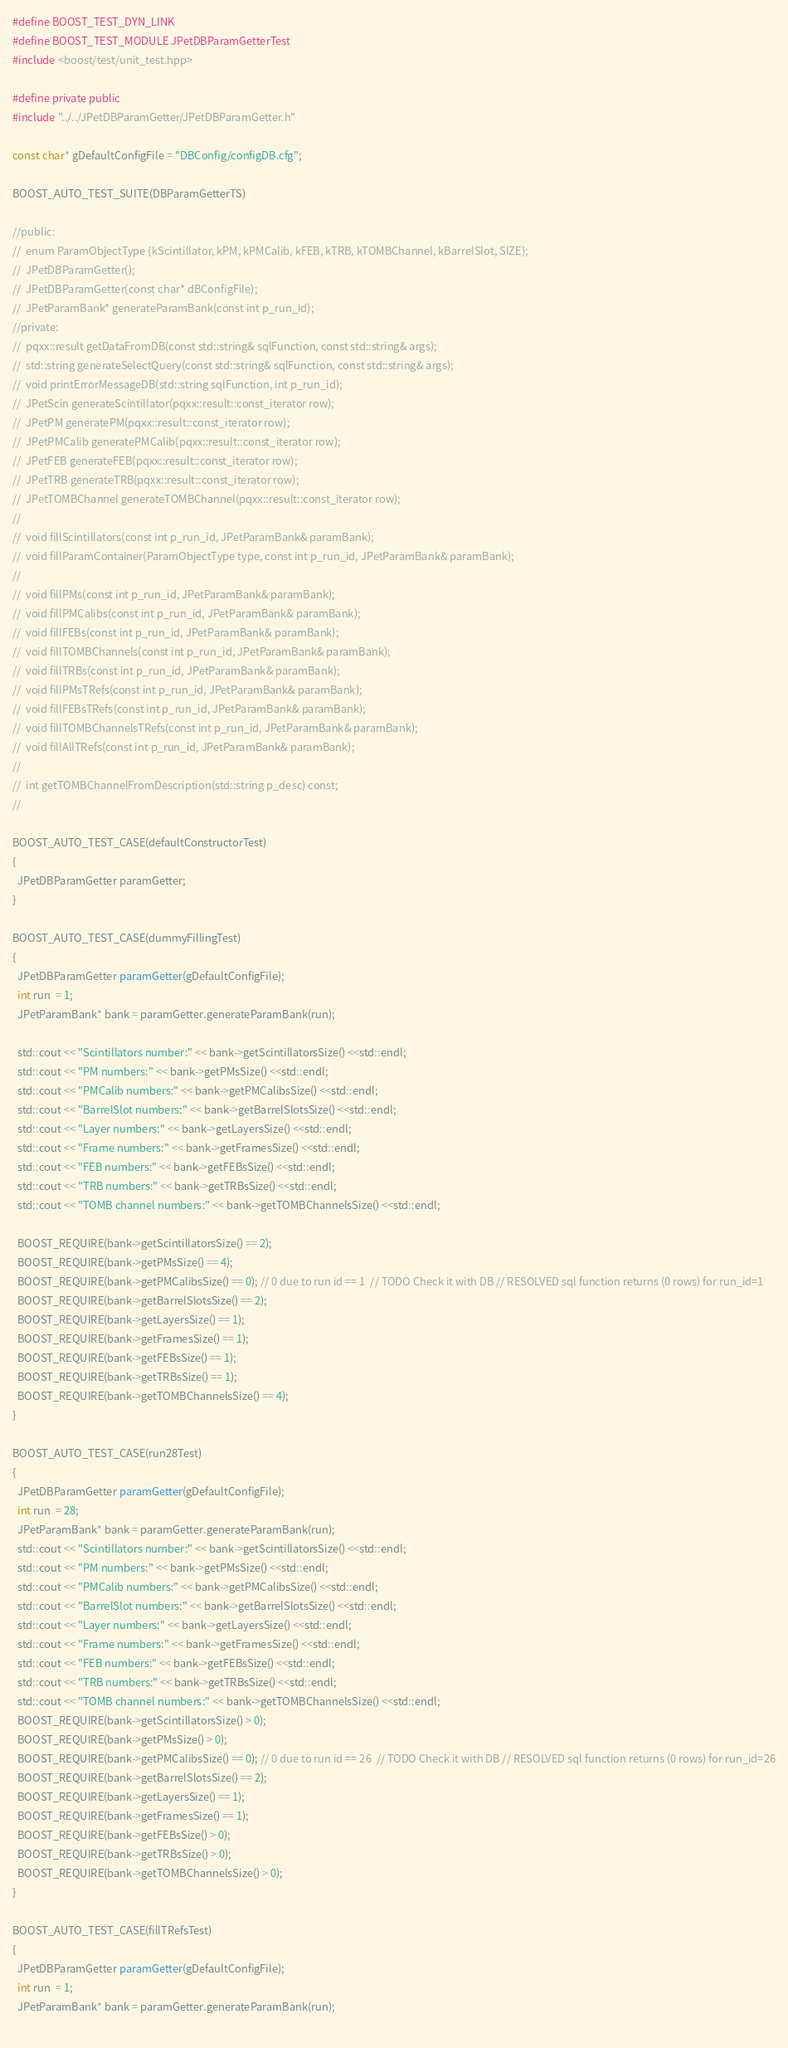Convert code to text. <code><loc_0><loc_0><loc_500><loc_500><_C++_>#define BOOST_TEST_DYN_LINK
#define BOOST_TEST_MODULE JPetDBParamGetterTest
#include <boost/test/unit_test.hpp>

#define private public
#include "../../JPetDBParamGetter/JPetDBParamGetter.h"

const char* gDefaultConfigFile = "DBConfig/configDB.cfg";

BOOST_AUTO_TEST_SUITE(DBParamGetterTS)

//public:
//  enum ParamObjectType {kScintillator, kPM, kPMCalib, kFEB, kTRB, kTOMBChannel, kBarrelSlot, SIZE};
//  JPetDBParamGetter();
//  JPetDBParamGetter(const char* dBConfigFile);
//  JPetParamBank* generateParamBank(const int p_run_id);
//private:
//  pqxx::result getDataFromDB(const std::string& sqlFunction, const std::string& args);
//  std::string generateSelectQuery(const std::string& sqlFunction, const std::string& args);
//  void printErrorMessageDB(std::string sqlFunction, int p_run_id);
//  JPetScin generateScintillator(pqxx::result::const_iterator row);
//  JPetPM generatePM(pqxx::result::const_iterator row);
//  JPetPMCalib generatePMCalib(pqxx::result::const_iterator row);
//  JPetFEB generateFEB(pqxx::result::const_iterator row);
//  JPetTRB generateTRB(pqxx::result::const_iterator row);
//  JPetTOMBChannel generateTOMBChannel(pqxx::result::const_iterator row);
//
//  void fillScintillators(const int p_run_id, JPetParamBank& paramBank);
//  void fillParamContainer(ParamObjectType type, const int p_run_id, JPetParamBank& paramBank);
//
//  void fillPMs(const int p_run_id, JPetParamBank& paramBank);
//  void fillPMCalibs(const int p_run_id, JPetParamBank& paramBank);
//  void fillFEBs(const int p_run_id, JPetParamBank& paramBank);
//  void fillTOMBChannels(const int p_run_id, JPetParamBank& paramBank);
//  void fillTRBs(const int p_run_id, JPetParamBank& paramBank);
//  void fillPMsTRefs(const int p_run_id, JPetParamBank& paramBank);
//  void fillFEBsTRefs(const int p_run_id, JPetParamBank& paramBank);
//  void fillTOMBChannelsTRefs(const int p_run_id, JPetParamBank& paramBank);
//  void fillAllTRefs(const int p_run_id, JPetParamBank& paramBank);
//
//  int getTOMBChannelFromDescription(std::string p_desc) const;
//

BOOST_AUTO_TEST_CASE(defaultConstructorTest)
{
  JPetDBParamGetter paramGetter;
}

BOOST_AUTO_TEST_CASE(dummyFillingTest)
{
  JPetDBParamGetter paramGetter(gDefaultConfigFile);
  int run  = 1;
  JPetParamBank* bank = paramGetter.generateParamBank(run);
  
  std::cout << "Scintillators number:" << bank->getScintillatorsSize() <<std::endl;
  std::cout << "PM numbers:" << bank->getPMsSize() <<std::endl;
  std::cout << "PMCalib numbers:" << bank->getPMCalibsSize() <<std::endl;
  std::cout << "BarrelSlot numbers:" << bank->getBarrelSlotsSize() <<std::endl;
  std::cout << "Layer numbers:" << bank->getLayersSize() <<std::endl;
  std::cout << "Frame numbers:" << bank->getFramesSize() <<std::endl;
  std::cout << "FEB numbers:" << bank->getFEBsSize() <<std::endl;
  std::cout << "TRB numbers:" << bank->getTRBsSize() <<std::endl;
  std::cout << "TOMB channel numbers:" << bank->getTOMBChannelsSize() <<std::endl;

  BOOST_REQUIRE(bank->getScintillatorsSize() == 2);
  BOOST_REQUIRE(bank->getPMsSize() == 4);
  BOOST_REQUIRE(bank->getPMCalibsSize() == 0); // 0 due to run id == 1  // TODO Check it with DB // RESOLVED sql function returns (0 rows) for run_id=1
  BOOST_REQUIRE(bank->getBarrelSlotsSize() == 2);
  BOOST_REQUIRE(bank->getLayersSize() == 1);
  BOOST_REQUIRE(bank->getFramesSize() == 1);
  BOOST_REQUIRE(bank->getFEBsSize() == 1);
  BOOST_REQUIRE(bank->getTRBsSize() == 1);
  BOOST_REQUIRE(bank->getTOMBChannelsSize() == 4);
}

BOOST_AUTO_TEST_CASE(run28Test)
{
  JPetDBParamGetter paramGetter(gDefaultConfigFile);
  int run  = 28;
  JPetParamBank* bank = paramGetter.generateParamBank(run);
  std::cout << "Scintillators number:" << bank->getScintillatorsSize() <<std::endl;
  std::cout << "PM numbers:" << bank->getPMsSize() <<std::endl;
  std::cout << "PMCalib numbers:" << bank->getPMCalibsSize() <<std::endl;
  std::cout << "BarrelSlot numbers:" << bank->getBarrelSlotsSize() <<std::endl;
  std::cout << "Layer numbers:" << bank->getLayersSize() <<std::endl;
  std::cout << "Frame numbers:" << bank->getFramesSize() <<std::endl;
  std::cout << "FEB numbers:" << bank->getFEBsSize() <<std::endl;
  std::cout << "TRB numbers:" << bank->getTRBsSize() <<std::endl;
  std::cout << "TOMB channel numbers:" << bank->getTOMBChannelsSize() <<std::endl;
  BOOST_REQUIRE(bank->getScintillatorsSize() > 0);
  BOOST_REQUIRE(bank->getPMsSize() > 0);
  BOOST_REQUIRE(bank->getPMCalibsSize() == 0); // 0 due to run id == 26  // TODO Check it with DB // RESOLVED sql function returns (0 rows) for run_id=26
  BOOST_REQUIRE(bank->getBarrelSlotsSize() == 2);
  BOOST_REQUIRE(bank->getLayersSize() == 1);
  BOOST_REQUIRE(bank->getFramesSize() == 1);
  BOOST_REQUIRE(bank->getFEBsSize() > 0);
  BOOST_REQUIRE(bank->getTRBsSize() > 0);
  BOOST_REQUIRE(bank->getTOMBChannelsSize() > 0);
}

BOOST_AUTO_TEST_CASE(fillTRefsTest)
{
  JPetDBParamGetter paramGetter(gDefaultConfigFile);
  int run  = 1;
  JPetParamBank* bank = paramGetter.generateParamBank(run);
  </code> 